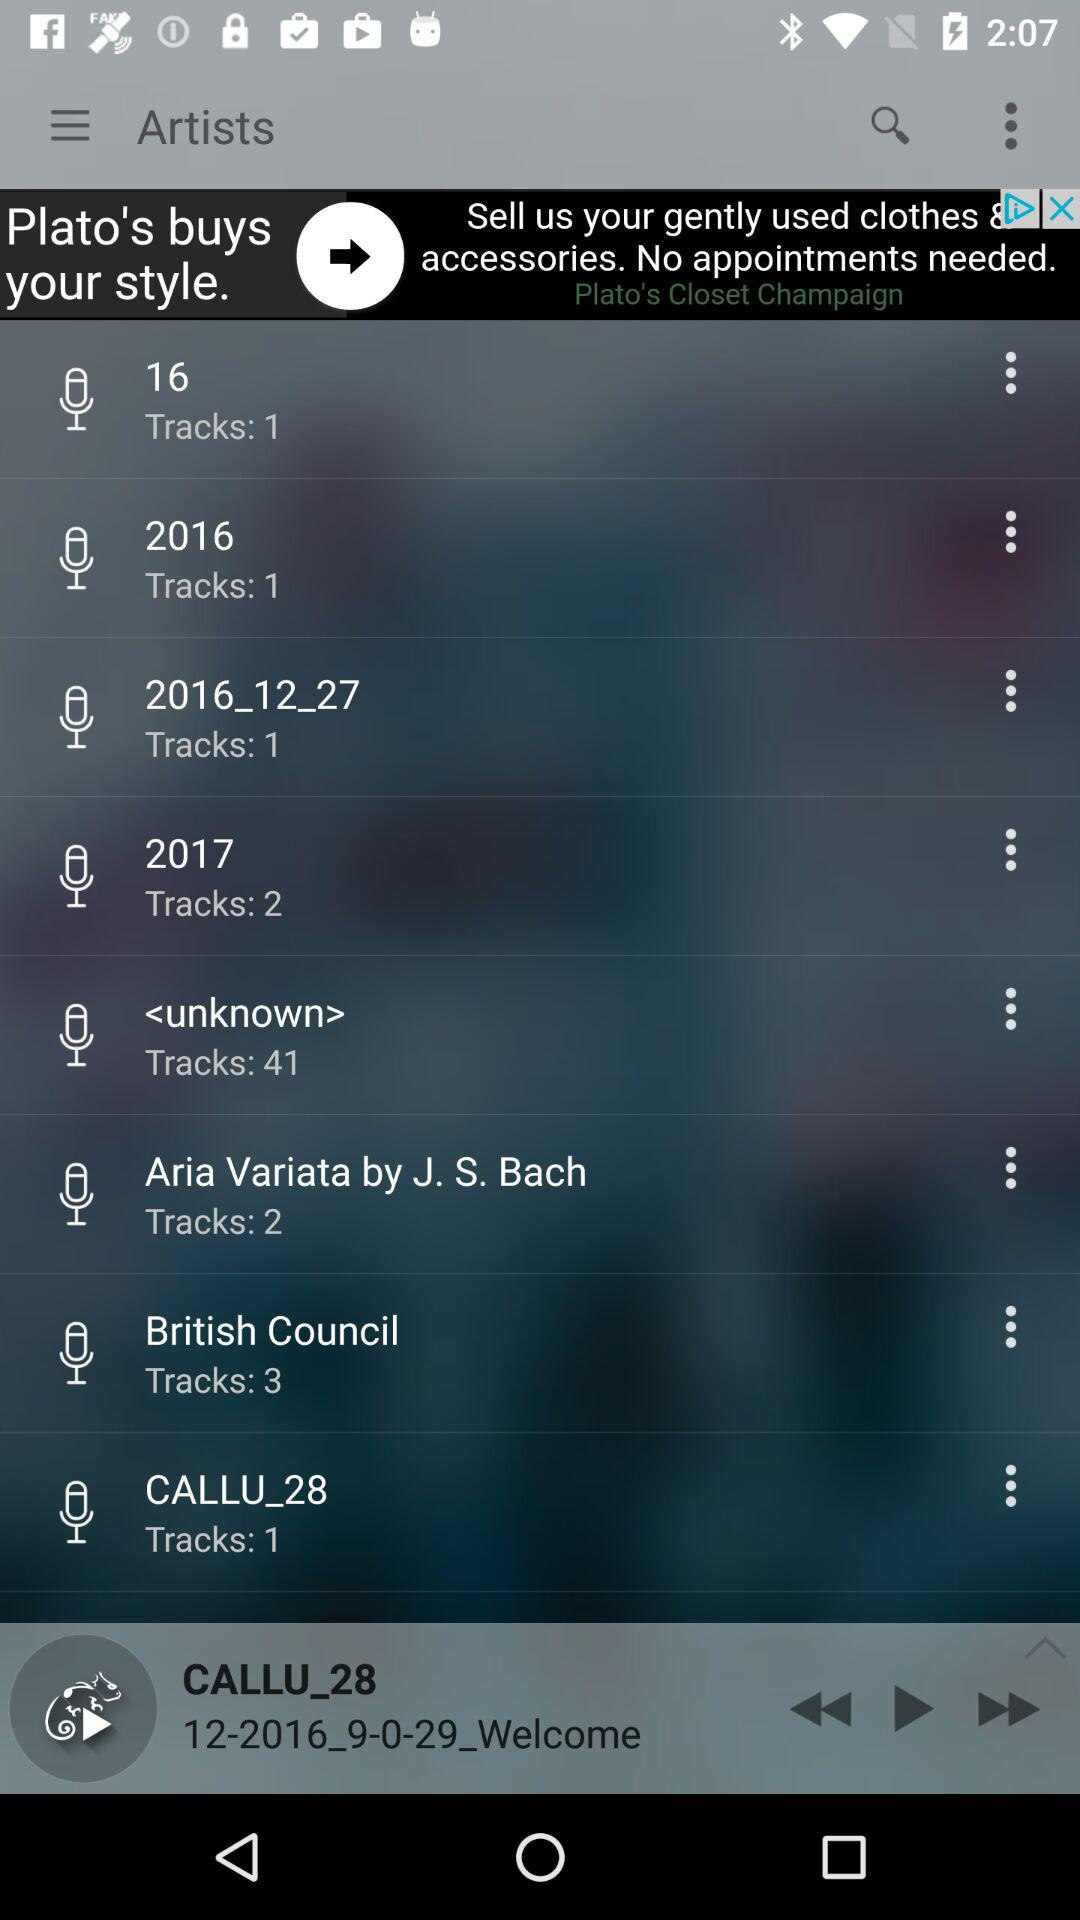How many tracks does the item with the text 'British Council' have?
Answer the question using a single word or phrase. 3 